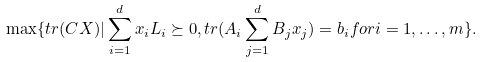Convert formula to latex. <formula><loc_0><loc_0><loc_500><loc_500>\max \{ t r ( C X ) | \sum _ { i = 1 } ^ { d } x _ { i } L _ { i } \succeq 0 , t r ( A _ { i } \sum _ { j = 1 } ^ { d } B _ { j } x _ { j } ) = b _ { i } f o r i = 1 , \dots , m \} .</formula> 